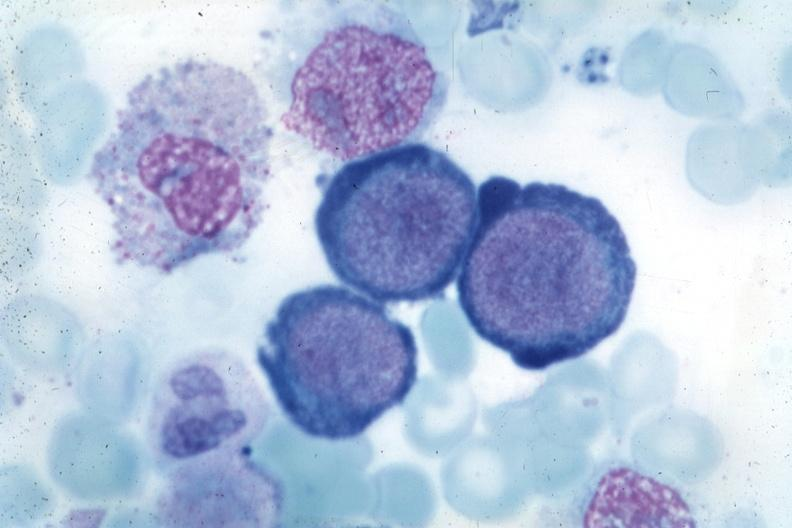what does this image show?
Answer the question using a single word or phrase. Wrights typical cells 